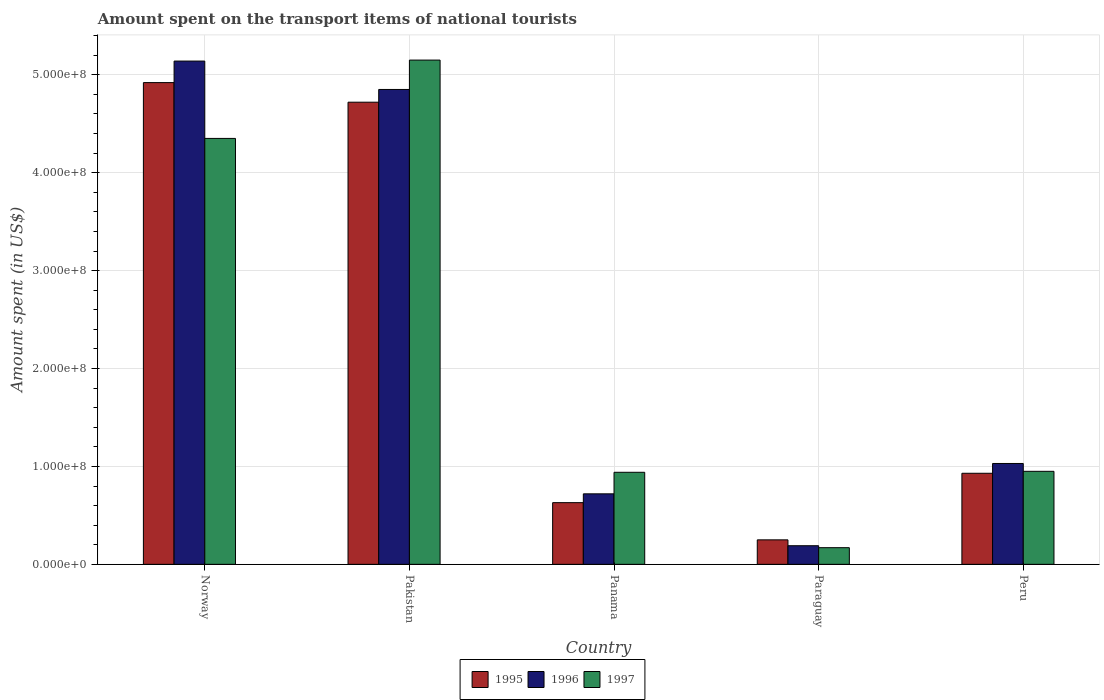What is the label of the 5th group of bars from the left?
Your answer should be compact. Peru. What is the amount spent on the transport items of national tourists in 1995 in Norway?
Keep it short and to the point. 4.92e+08. Across all countries, what is the maximum amount spent on the transport items of national tourists in 1996?
Provide a short and direct response. 5.14e+08. Across all countries, what is the minimum amount spent on the transport items of national tourists in 1996?
Offer a very short reply. 1.90e+07. In which country was the amount spent on the transport items of national tourists in 1995 minimum?
Provide a short and direct response. Paraguay. What is the total amount spent on the transport items of national tourists in 1996 in the graph?
Your answer should be compact. 1.19e+09. What is the difference between the amount spent on the transport items of national tourists in 1997 in Paraguay and that in Peru?
Offer a very short reply. -7.80e+07. What is the difference between the amount spent on the transport items of national tourists in 1995 in Norway and the amount spent on the transport items of national tourists in 1996 in Pakistan?
Your answer should be very brief. 7.00e+06. What is the average amount spent on the transport items of national tourists in 1995 per country?
Provide a succinct answer. 2.29e+08. What is the ratio of the amount spent on the transport items of national tourists in 1997 in Norway to that in Peru?
Make the answer very short. 4.58. What is the difference between the highest and the second highest amount spent on the transport items of national tourists in 1995?
Keep it short and to the point. 2.00e+07. What is the difference between the highest and the lowest amount spent on the transport items of national tourists in 1996?
Give a very brief answer. 4.95e+08. What does the 3rd bar from the right in Peru represents?
Give a very brief answer. 1995. How many bars are there?
Provide a short and direct response. 15. How many countries are there in the graph?
Your response must be concise. 5. Are the values on the major ticks of Y-axis written in scientific E-notation?
Offer a terse response. Yes. Does the graph contain grids?
Offer a terse response. Yes. What is the title of the graph?
Give a very brief answer. Amount spent on the transport items of national tourists. Does "1988" appear as one of the legend labels in the graph?
Your response must be concise. No. What is the label or title of the X-axis?
Keep it short and to the point. Country. What is the label or title of the Y-axis?
Provide a short and direct response. Amount spent (in US$). What is the Amount spent (in US$) in 1995 in Norway?
Provide a short and direct response. 4.92e+08. What is the Amount spent (in US$) of 1996 in Norway?
Offer a terse response. 5.14e+08. What is the Amount spent (in US$) of 1997 in Norway?
Your response must be concise. 4.35e+08. What is the Amount spent (in US$) of 1995 in Pakistan?
Your answer should be very brief. 4.72e+08. What is the Amount spent (in US$) of 1996 in Pakistan?
Provide a short and direct response. 4.85e+08. What is the Amount spent (in US$) of 1997 in Pakistan?
Your answer should be compact. 5.15e+08. What is the Amount spent (in US$) in 1995 in Panama?
Make the answer very short. 6.30e+07. What is the Amount spent (in US$) of 1996 in Panama?
Your answer should be very brief. 7.20e+07. What is the Amount spent (in US$) in 1997 in Panama?
Provide a short and direct response. 9.40e+07. What is the Amount spent (in US$) of 1995 in Paraguay?
Offer a terse response. 2.50e+07. What is the Amount spent (in US$) in 1996 in Paraguay?
Your answer should be compact. 1.90e+07. What is the Amount spent (in US$) of 1997 in Paraguay?
Make the answer very short. 1.70e+07. What is the Amount spent (in US$) of 1995 in Peru?
Your answer should be compact. 9.30e+07. What is the Amount spent (in US$) in 1996 in Peru?
Make the answer very short. 1.03e+08. What is the Amount spent (in US$) in 1997 in Peru?
Make the answer very short. 9.50e+07. Across all countries, what is the maximum Amount spent (in US$) in 1995?
Give a very brief answer. 4.92e+08. Across all countries, what is the maximum Amount spent (in US$) in 1996?
Keep it short and to the point. 5.14e+08. Across all countries, what is the maximum Amount spent (in US$) of 1997?
Make the answer very short. 5.15e+08. Across all countries, what is the minimum Amount spent (in US$) of 1995?
Keep it short and to the point. 2.50e+07. Across all countries, what is the minimum Amount spent (in US$) in 1996?
Make the answer very short. 1.90e+07. Across all countries, what is the minimum Amount spent (in US$) in 1997?
Your answer should be very brief. 1.70e+07. What is the total Amount spent (in US$) of 1995 in the graph?
Your response must be concise. 1.14e+09. What is the total Amount spent (in US$) in 1996 in the graph?
Provide a succinct answer. 1.19e+09. What is the total Amount spent (in US$) in 1997 in the graph?
Keep it short and to the point. 1.16e+09. What is the difference between the Amount spent (in US$) of 1995 in Norway and that in Pakistan?
Your answer should be very brief. 2.00e+07. What is the difference between the Amount spent (in US$) in 1996 in Norway and that in Pakistan?
Offer a very short reply. 2.90e+07. What is the difference between the Amount spent (in US$) in 1997 in Norway and that in Pakistan?
Ensure brevity in your answer.  -8.00e+07. What is the difference between the Amount spent (in US$) of 1995 in Norway and that in Panama?
Your answer should be very brief. 4.29e+08. What is the difference between the Amount spent (in US$) of 1996 in Norway and that in Panama?
Ensure brevity in your answer.  4.42e+08. What is the difference between the Amount spent (in US$) in 1997 in Norway and that in Panama?
Ensure brevity in your answer.  3.41e+08. What is the difference between the Amount spent (in US$) in 1995 in Norway and that in Paraguay?
Your answer should be very brief. 4.67e+08. What is the difference between the Amount spent (in US$) of 1996 in Norway and that in Paraguay?
Provide a short and direct response. 4.95e+08. What is the difference between the Amount spent (in US$) of 1997 in Norway and that in Paraguay?
Your answer should be compact. 4.18e+08. What is the difference between the Amount spent (in US$) in 1995 in Norway and that in Peru?
Give a very brief answer. 3.99e+08. What is the difference between the Amount spent (in US$) of 1996 in Norway and that in Peru?
Your answer should be compact. 4.11e+08. What is the difference between the Amount spent (in US$) in 1997 in Norway and that in Peru?
Provide a short and direct response. 3.40e+08. What is the difference between the Amount spent (in US$) of 1995 in Pakistan and that in Panama?
Your response must be concise. 4.09e+08. What is the difference between the Amount spent (in US$) of 1996 in Pakistan and that in Panama?
Offer a very short reply. 4.13e+08. What is the difference between the Amount spent (in US$) in 1997 in Pakistan and that in Panama?
Offer a very short reply. 4.21e+08. What is the difference between the Amount spent (in US$) in 1995 in Pakistan and that in Paraguay?
Make the answer very short. 4.47e+08. What is the difference between the Amount spent (in US$) of 1996 in Pakistan and that in Paraguay?
Your answer should be compact. 4.66e+08. What is the difference between the Amount spent (in US$) in 1997 in Pakistan and that in Paraguay?
Your answer should be compact. 4.98e+08. What is the difference between the Amount spent (in US$) of 1995 in Pakistan and that in Peru?
Offer a very short reply. 3.79e+08. What is the difference between the Amount spent (in US$) in 1996 in Pakistan and that in Peru?
Your response must be concise. 3.82e+08. What is the difference between the Amount spent (in US$) in 1997 in Pakistan and that in Peru?
Provide a short and direct response. 4.20e+08. What is the difference between the Amount spent (in US$) of 1995 in Panama and that in Paraguay?
Your answer should be very brief. 3.80e+07. What is the difference between the Amount spent (in US$) of 1996 in Panama and that in Paraguay?
Your response must be concise. 5.30e+07. What is the difference between the Amount spent (in US$) in 1997 in Panama and that in Paraguay?
Ensure brevity in your answer.  7.70e+07. What is the difference between the Amount spent (in US$) of 1995 in Panama and that in Peru?
Give a very brief answer. -3.00e+07. What is the difference between the Amount spent (in US$) in 1996 in Panama and that in Peru?
Provide a succinct answer. -3.10e+07. What is the difference between the Amount spent (in US$) of 1995 in Paraguay and that in Peru?
Provide a short and direct response. -6.80e+07. What is the difference between the Amount spent (in US$) in 1996 in Paraguay and that in Peru?
Keep it short and to the point. -8.40e+07. What is the difference between the Amount spent (in US$) of 1997 in Paraguay and that in Peru?
Provide a succinct answer. -7.80e+07. What is the difference between the Amount spent (in US$) of 1995 in Norway and the Amount spent (in US$) of 1997 in Pakistan?
Make the answer very short. -2.30e+07. What is the difference between the Amount spent (in US$) in 1995 in Norway and the Amount spent (in US$) in 1996 in Panama?
Your answer should be very brief. 4.20e+08. What is the difference between the Amount spent (in US$) in 1995 in Norway and the Amount spent (in US$) in 1997 in Panama?
Your answer should be very brief. 3.98e+08. What is the difference between the Amount spent (in US$) of 1996 in Norway and the Amount spent (in US$) of 1997 in Panama?
Your response must be concise. 4.20e+08. What is the difference between the Amount spent (in US$) of 1995 in Norway and the Amount spent (in US$) of 1996 in Paraguay?
Your answer should be compact. 4.73e+08. What is the difference between the Amount spent (in US$) in 1995 in Norway and the Amount spent (in US$) in 1997 in Paraguay?
Make the answer very short. 4.75e+08. What is the difference between the Amount spent (in US$) in 1996 in Norway and the Amount spent (in US$) in 1997 in Paraguay?
Make the answer very short. 4.97e+08. What is the difference between the Amount spent (in US$) in 1995 in Norway and the Amount spent (in US$) in 1996 in Peru?
Keep it short and to the point. 3.89e+08. What is the difference between the Amount spent (in US$) in 1995 in Norway and the Amount spent (in US$) in 1997 in Peru?
Make the answer very short. 3.97e+08. What is the difference between the Amount spent (in US$) of 1996 in Norway and the Amount spent (in US$) of 1997 in Peru?
Your answer should be compact. 4.19e+08. What is the difference between the Amount spent (in US$) in 1995 in Pakistan and the Amount spent (in US$) in 1996 in Panama?
Provide a succinct answer. 4.00e+08. What is the difference between the Amount spent (in US$) of 1995 in Pakistan and the Amount spent (in US$) of 1997 in Panama?
Offer a very short reply. 3.78e+08. What is the difference between the Amount spent (in US$) of 1996 in Pakistan and the Amount spent (in US$) of 1997 in Panama?
Your response must be concise. 3.91e+08. What is the difference between the Amount spent (in US$) of 1995 in Pakistan and the Amount spent (in US$) of 1996 in Paraguay?
Keep it short and to the point. 4.53e+08. What is the difference between the Amount spent (in US$) in 1995 in Pakistan and the Amount spent (in US$) in 1997 in Paraguay?
Provide a succinct answer. 4.55e+08. What is the difference between the Amount spent (in US$) in 1996 in Pakistan and the Amount spent (in US$) in 1997 in Paraguay?
Provide a succinct answer. 4.68e+08. What is the difference between the Amount spent (in US$) in 1995 in Pakistan and the Amount spent (in US$) in 1996 in Peru?
Give a very brief answer. 3.69e+08. What is the difference between the Amount spent (in US$) of 1995 in Pakistan and the Amount spent (in US$) of 1997 in Peru?
Your answer should be compact. 3.77e+08. What is the difference between the Amount spent (in US$) in 1996 in Pakistan and the Amount spent (in US$) in 1997 in Peru?
Keep it short and to the point. 3.90e+08. What is the difference between the Amount spent (in US$) in 1995 in Panama and the Amount spent (in US$) in 1996 in Paraguay?
Give a very brief answer. 4.40e+07. What is the difference between the Amount spent (in US$) in 1995 in Panama and the Amount spent (in US$) in 1997 in Paraguay?
Your response must be concise. 4.60e+07. What is the difference between the Amount spent (in US$) in 1996 in Panama and the Amount spent (in US$) in 1997 in Paraguay?
Keep it short and to the point. 5.50e+07. What is the difference between the Amount spent (in US$) of 1995 in Panama and the Amount spent (in US$) of 1996 in Peru?
Ensure brevity in your answer.  -4.00e+07. What is the difference between the Amount spent (in US$) of 1995 in Panama and the Amount spent (in US$) of 1997 in Peru?
Provide a short and direct response. -3.20e+07. What is the difference between the Amount spent (in US$) of 1996 in Panama and the Amount spent (in US$) of 1997 in Peru?
Keep it short and to the point. -2.30e+07. What is the difference between the Amount spent (in US$) of 1995 in Paraguay and the Amount spent (in US$) of 1996 in Peru?
Provide a short and direct response. -7.80e+07. What is the difference between the Amount spent (in US$) of 1995 in Paraguay and the Amount spent (in US$) of 1997 in Peru?
Your answer should be compact. -7.00e+07. What is the difference between the Amount spent (in US$) of 1996 in Paraguay and the Amount spent (in US$) of 1997 in Peru?
Your answer should be very brief. -7.60e+07. What is the average Amount spent (in US$) of 1995 per country?
Give a very brief answer. 2.29e+08. What is the average Amount spent (in US$) of 1996 per country?
Your answer should be very brief. 2.39e+08. What is the average Amount spent (in US$) in 1997 per country?
Make the answer very short. 2.31e+08. What is the difference between the Amount spent (in US$) of 1995 and Amount spent (in US$) of 1996 in Norway?
Make the answer very short. -2.20e+07. What is the difference between the Amount spent (in US$) in 1995 and Amount spent (in US$) in 1997 in Norway?
Give a very brief answer. 5.70e+07. What is the difference between the Amount spent (in US$) of 1996 and Amount spent (in US$) of 1997 in Norway?
Provide a succinct answer. 7.90e+07. What is the difference between the Amount spent (in US$) in 1995 and Amount spent (in US$) in 1996 in Pakistan?
Your answer should be very brief. -1.30e+07. What is the difference between the Amount spent (in US$) in 1995 and Amount spent (in US$) in 1997 in Pakistan?
Your answer should be compact. -4.30e+07. What is the difference between the Amount spent (in US$) in 1996 and Amount spent (in US$) in 1997 in Pakistan?
Keep it short and to the point. -3.00e+07. What is the difference between the Amount spent (in US$) of 1995 and Amount spent (in US$) of 1996 in Panama?
Keep it short and to the point. -9.00e+06. What is the difference between the Amount spent (in US$) in 1995 and Amount spent (in US$) in 1997 in Panama?
Keep it short and to the point. -3.10e+07. What is the difference between the Amount spent (in US$) of 1996 and Amount spent (in US$) of 1997 in Panama?
Your response must be concise. -2.20e+07. What is the difference between the Amount spent (in US$) of 1995 and Amount spent (in US$) of 1996 in Paraguay?
Offer a terse response. 6.00e+06. What is the difference between the Amount spent (in US$) of 1996 and Amount spent (in US$) of 1997 in Paraguay?
Your answer should be compact. 2.00e+06. What is the difference between the Amount spent (in US$) of 1995 and Amount spent (in US$) of 1996 in Peru?
Give a very brief answer. -1.00e+07. What is the ratio of the Amount spent (in US$) in 1995 in Norway to that in Pakistan?
Provide a succinct answer. 1.04. What is the ratio of the Amount spent (in US$) in 1996 in Norway to that in Pakistan?
Provide a short and direct response. 1.06. What is the ratio of the Amount spent (in US$) of 1997 in Norway to that in Pakistan?
Offer a very short reply. 0.84. What is the ratio of the Amount spent (in US$) in 1995 in Norway to that in Panama?
Offer a terse response. 7.81. What is the ratio of the Amount spent (in US$) in 1996 in Norway to that in Panama?
Provide a short and direct response. 7.14. What is the ratio of the Amount spent (in US$) in 1997 in Norway to that in Panama?
Provide a short and direct response. 4.63. What is the ratio of the Amount spent (in US$) in 1995 in Norway to that in Paraguay?
Make the answer very short. 19.68. What is the ratio of the Amount spent (in US$) in 1996 in Norway to that in Paraguay?
Keep it short and to the point. 27.05. What is the ratio of the Amount spent (in US$) of 1997 in Norway to that in Paraguay?
Make the answer very short. 25.59. What is the ratio of the Amount spent (in US$) in 1995 in Norway to that in Peru?
Offer a very short reply. 5.29. What is the ratio of the Amount spent (in US$) in 1996 in Norway to that in Peru?
Offer a very short reply. 4.99. What is the ratio of the Amount spent (in US$) of 1997 in Norway to that in Peru?
Provide a succinct answer. 4.58. What is the ratio of the Amount spent (in US$) in 1995 in Pakistan to that in Panama?
Ensure brevity in your answer.  7.49. What is the ratio of the Amount spent (in US$) of 1996 in Pakistan to that in Panama?
Ensure brevity in your answer.  6.74. What is the ratio of the Amount spent (in US$) of 1997 in Pakistan to that in Panama?
Provide a succinct answer. 5.48. What is the ratio of the Amount spent (in US$) of 1995 in Pakistan to that in Paraguay?
Offer a terse response. 18.88. What is the ratio of the Amount spent (in US$) of 1996 in Pakistan to that in Paraguay?
Offer a terse response. 25.53. What is the ratio of the Amount spent (in US$) of 1997 in Pakistan to that in Paraguay?
Make the answer very short. 30.29. What is the ratio of the Amount spent (in US$) of 1995 in Pakistan to that in Peru?
Make the answer very short. 5.08. What is the ratio of the Amount spent (in US$) of 1996 in Pakistan to that in Peru?
Your answer should be compact. 4.71. What is the ratio of the Amount spent (in US$) in 1997 in Pakistan to that in Peru?
Your answer should be very brief. 5.42. What is the ratio of the Amount spent (in US$) of 1995 in Panama to that in Paraguay?
Keep it short and to the point. 2.52. What is the ratio of the Amount spent (in US$) of 1996 in Panama to that in Paraguay?
Give a very brief answer. 3.79. What is the ratio of the Amount spent (in US$) in 1997 in Panama to that in Paraguay?
Provide a short and direct response. 5.53. What is the ratio of the Amount spent (in US$) of 1995 in Panama to that in Peru?
Offer a very short reply. 0.68. What is the ratio of the Amount spent (in US$) in 1996 in Panama to that in Peru?
Your answer should be very brief. 0.7. What is the ratio of the Amount spent (in US$) of 1995 in Paraguay to that in Peru?
Ensure brevity in your answer.  0.27. What is the ratio of the Amount spent (in US$) of 1996 in Paraguay to that in Peru?
Ensure brevity in your answer.  0.18. What is the ratio of the Amount spent (in US$) in 1997 in Paraguay to that in Peru?
Your answer should be compact. 0.18. What is the difference between the highest and the second highest Amount spent (in US$) of 1996?
Offer a very short reply. 2.90e+07. What is the difference between the highest and the second highest Amount spent (in US$) of 1997?
Make the answer very short. 8.00e+07. What is the difference between the highest and the lowest Amount spent (in US$) of 1995?
Ensure brevity in your answer.  4.67e+08. What is the difference between the highest and the lowest Amount spent (in US$) of 1996?
Make the answer very short. 4.95e+08. What is the difference between the highest and the lowest Amount spent (in US$) in 1997?
Your response must be concise. 4.98e+08. 